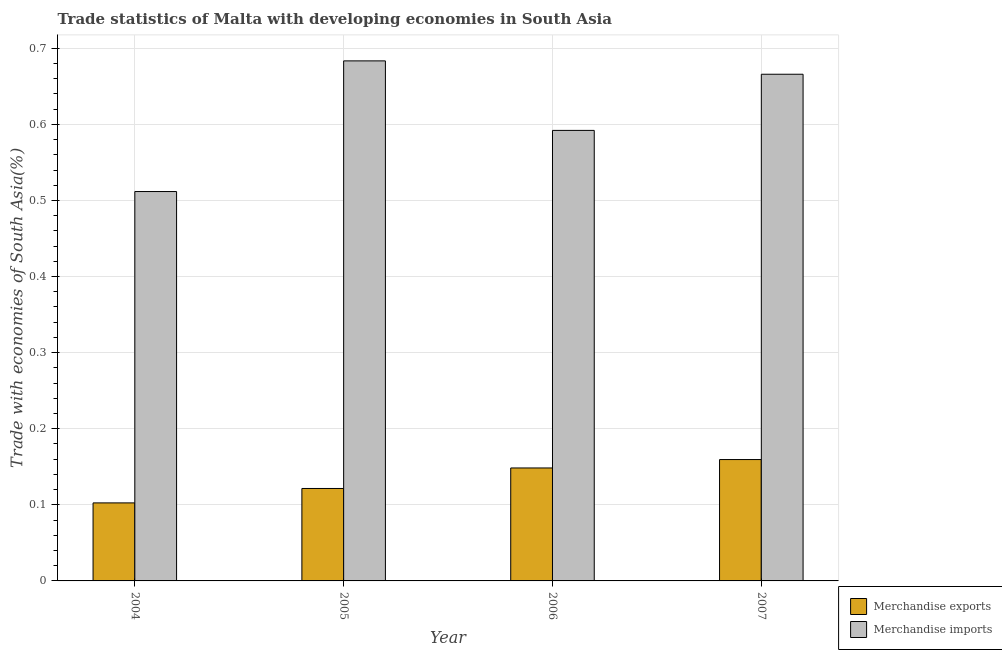How many different coloured bars are there?
Your answer should be very brief. 2. Are the number of bars per tick equal to the number of legend labels?
Offer a very short reply. Yes. How many bars are there on the 4th tick from the right?
Provide a short and direct response. 2. What is the merchandise exports in 2006?
Make the answer very short. 0.15. Across all years, what is the maximum merchandise exports?
Your answer should be compact. 0.16. Across all years, what is the minimum merchandise imports?
Give a very brief answer. 0.51. What is the total merchandise exports in the graph?
Give a very brief answer. 0.53. What is the difference between the merchandise exports in 2004 and that in 2007?
Give a very brief answer. -0.06. What is the difference between the merchandise imports in 2005 and the merchandise exports in 2006?
Make the answer very short. 0.09. What is the average merchandise exports per year?
Offer a very short reply. 0.13. In the year 2005, what is the difference between the merchandise imports and merchandise exports?
Ensure brevity in your answer.  0. What is the ratio of the merchandise exports in 2004 to that in 2005?
Your answer should be very brief. 0.84. Is the merchandise exports in 2004 less than that in 2005?
Your response must be concise. Yes. Is the difference between the merchandise imports in 2004 and 2007 greater than the difference between the merchandise exports in 2004 and 2007?
Give a very brief answer. No. What is the difference between the highest and the second highest merchandise exports?
Your answer should be compact. 0.01. What is the difference between the highest and the lowest merchandise imports?
Make the answer very short. 0.17. Is the sum of the merchandise exports in 2005 and 2006 greater than the maximum merchandise imports across all years?
Your answer should be very brief. Yes. What does the 1st bar from the right in 2007 represents?
Offer a very short reply. Merchandise imports. Are all the bars in the graph horizontal?
Keep it short and to the point. No. What is the difference between two consecutive major ticks on the Y-axis?
Ensure brevity in your answer.  0.1. Does the graph contain any zero values?
Your answer should be compact. No. Where does the legend appear in the graph?
Provide a short and direct response. Bottom right. What is the title of the graph?
Keep it short and to the point. Trade statistics of Malta with developing economies in South Asia. Does "Age 65(female)" appear as one of the legend labels in the graph?
Your response must be concise. No. What is the label or title of the X-axis?
Offer a very short reply. Year. What is the label or title of the Y-axis?
Your answer should be very brief. Trade with economies of South Asia(%). What is the Trade with economies of South Asia(%) of Merchandise exports in 2004?
Offer a terse response. 0.1. What is the Trade with economies of South Asia(%) in Merchandise imports in 2004?
Your answer should be compact. 0.51. What is the Trade with economies of South Asia(%) of Merchandise exports in 2005?
Your answer should be compact. 0.12. What is the Trade with economies of South Asia(%) in Merchandise imports in 2005?
Offer a terse response. 0.68. What is the Trade with economies of South Asia(%) of Merchandise exports in 2006?
Your answer should be compact. 0.15. What is the Trade with economies of South Asia(%) in Merchandise imports in 2006?
Provide a short and direct response. 0.59. What is the Trade with economies of South Asia(%) in Merchandise exports in 2007?
Offer a terse response. 0.16. What is the Trade with economies of South Asia(%) of Merchandise imports in 2007?
Your answer should be very brief. 0.67. Across all years, what is the maximum Trade with economies of South Asia(%) of Merchandise exports?
Your answer should be compact. 0.16. Across all years, what is the maximum Trade with economies of South Asia(%) of Merchandise imports?
Offer a terse response. 0.68. Across all years, what is the minimum Trade with economies of South Asia(%) in Merchandise exports?
Give a very brief answer. 0.1. Across all years, what is the minimum Trade with economies of South Asia(%) of Merchandise imports?
Provide a succinct answer. 0.51. What is the total Trade with economies of South Asia(%) in Merchandise exports in the graph?
Ensure brevity in your answer.  0.53. What is the total Trade with economies of South Asia(%) of Merchandise imports in the graph?
Your answer should be very brief. 2.45. What is the difference between the Trade with economies of South Asia(%) of Merchandise exports in 2004 and that in 2005?
Your response must be concise. -0.02. What is the difference between the Trade with economies of South Asia(%) of Merchandise imports in 2004 and that in 2005?
Your answer should be very brief. -0.17. What is the difference between the Trade with economies of South Asia(%) of Merchandise exports in 2004 and that in 2006?
Your answer should be compact. -0.05. What is the difference between the Trade with economies of South Asia(%) in Merchandise imports in 2004 and that in 2006?
Offer a very short reply. -0.08. What is the difference between the Trade with economies of South Asia(%) in Merchandise exports in 2004 and that in 2007?
Provide a short and direct response. -0.06. What is the difference between the Trade with economies of South Asia(%) of Merchandise imports in 2004 and that in 2007?
Ensure brevity in your answer.  -0.15. What is the difference between the Trade with economies of South Asia(%) of Merchandise exports in 2005 and that in 2006?
Give a very brief answer. -0.03. What is the difference between the Trade with economies of South Asia(%) in Merchandise imports in 2005 and that in 2006?
Your answer should be compact. 0.09. What is the difference between the Trade with economies of South Asia(%) of Merchandise exports in 2005 and that in 2007?
Keep it short and to the point. -0.04. What is the difference between the Trade with economies of South Asia(%) of Merchandise imports in 2005 and that in 2007?
Your answer should be very brief. 0.02. What is the difference between the Trade with economies of South Asia(%) of Merchandise exports in 2006 and that in 2007?
Offer a very short reply. -0.01. What is the difference between the Trade with economies of South Asia(%) of Merchandise imports in 2006 and that in 2007?
Your response must be concise. -0.07. What is the difference between the Trade with economies of South Asia(%) in Merchandise exports in 2004 and the Trade with economies of South Asia(%) in Merchandise imports in 2005?
Your answer should be very brief. -0.58. What is the difference between the Trade with economies of South Asia(%) of Merchandise exports in 2004 and the Trade with economies of South Asia(%) of Merchandise imports in 2006?
Give a very brief answer. -0.49. What is the difference between the Trade with economies of South Asia(%) in Merchandise exports in 2004 and the Trade with economies of South Asia(%) in Merchandise imports in 2007?
Provide a succinct answer. -0.56. What is the difference between the Trade with economies of South Asia(%) in Merchandise exports in 2005 and the Trade with economies of South Asia(%) in Merchandise imports in 2006?
Your answer should be very brief. -0.47. What is the difference between the Trade with economies of South Asia(%) of Merchandise exports in 2005 and the Trade with economies of South Asia(%) of Merchandise imports in 2007?
Provide a succinct answer. -0.54. What is the difference between the Trade with economies of South Asia(%) in Merchandise exports in 2006 and the Trade with economies of South Asia(%) in Merchandise imports in 2007?
Your response must be concise. -0.52. What is the average Trade with economies of South Asia(%) in Merchandise exports per year?
Provide a short and direct response. 0.13. What is the average Trade with economies of South Asia(%) of Merchandise imports per year?
Your response must be concise. 0.61. In the year 2004, what is the difference between the Trade with economies of South Asia(%) in Merchandise exports and Trade with economies of South Asia(%) in Merchandise imports?
Offer a very short reply. -0.41. In the year 2005, what is the difference between the Trade with economies of South Asia(%) of Merchandise exports and Trade with economies of South Asia(%) of Merchandise imports?
Your answer should be compact. -0.56. In the year 2006, what is the difference between the Trade with economies of South Asia(%) in Merchandise exports and Trade with economies of South Asia(%) in Merchandise imports?
Make the answer very short. -0.44. In the year 2007, what is the difference between the Trade with economies of South Asia(%) in Merchandise exports and Trade with economies of South Asia(%) in Merchandise imports?
Provide a succinct answer. -0.51. What is the ratio of the Trade with economies of South Asia(%) in Merchandise exports in 2004 to that in 2005?
Offer a terse response. 0.84. What is the ratio of the Trade with economies of South Asia(%) in Merchandise imports in 2004 to that in 2005?
Offer a terse response. 0.75. What is the ratio of the Trade with economies of South Asia(%) in Merchandise exports in 2004 to that in 2006?
Provide a succinct answer. 0.69. What is the ratio of the Trade with economies of South Asia(%) of Merchandise imports in 2004 to that in 2006?
Your answer should be very brief. 0.86. What is the ratio of the Trade with economies of South Asia(%) in Merchandise exports in 2004 to that in 2007?
Keep it short and to the point. 0.64. What is the ratio of the Trade with economies of South Asia(%) of Merchandise imports in 2004 to that in 2007?
Ensure brevity in your answer.  0.77. What is the ratio of the Trade with economies of South Asia(%) of Merchandise exports in 2005 to that in 2006?
Keep it short and to the point. 0.82. What is the ratio of the Trade with economies of South Asia(%) of Merchandise imports in 2005 to that in 2006?
Your answer should be compact. 1.15. What is the ratio of the Trade with economies of South Asia(%) of Merchandise exports in 2005 to that in 2007?
Offer a terse response. 0.76. What is the ratio of the Trade with economies of South Asia(%) in Merchandise imports in 2005 to that in 2007?
Give a very brief answer. 1.03. What is the ratio of the Trade with economies of South Asia(%) in Merchandise exports in 2006 to that in 2007?
Your response must be concise. 0.93. What is the ratio of the Trade with economies of South Asia(%) in Merchandise imports in 2006 to that in 2007?
Ensure brevity in your answer.  0.89. What is the difference between the highest and the second highest Trade with economies of South Asia(%) of Merchandise exports?
Your response must be concise. 0.01. What is the difference between the highest and the second highest Trade with economies of South Asia(%) in Merchandise imports?
Keep it short and to the point. 0.02. What is the difference between the highest and the lowest Trade with economies of South Asia(%) in Merchandise exports?
Ensure brevity in your answer.  0.06. What is the difference between the highest and the lowest Trade with economies of South Asia(%) in Merchandise imports?
Offer a very short reply. 0.17. 